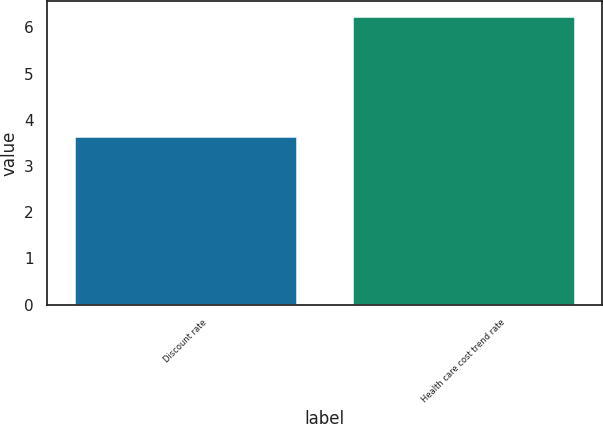Convert chart to OTSL. <chart><loc_0><loc_0><loc_500><loc_500><bar_chart><fcel>Discount rate<fcel>Health care cost trend rate<nl><fcel>3.66<fcel>6.25<nl></chart> 